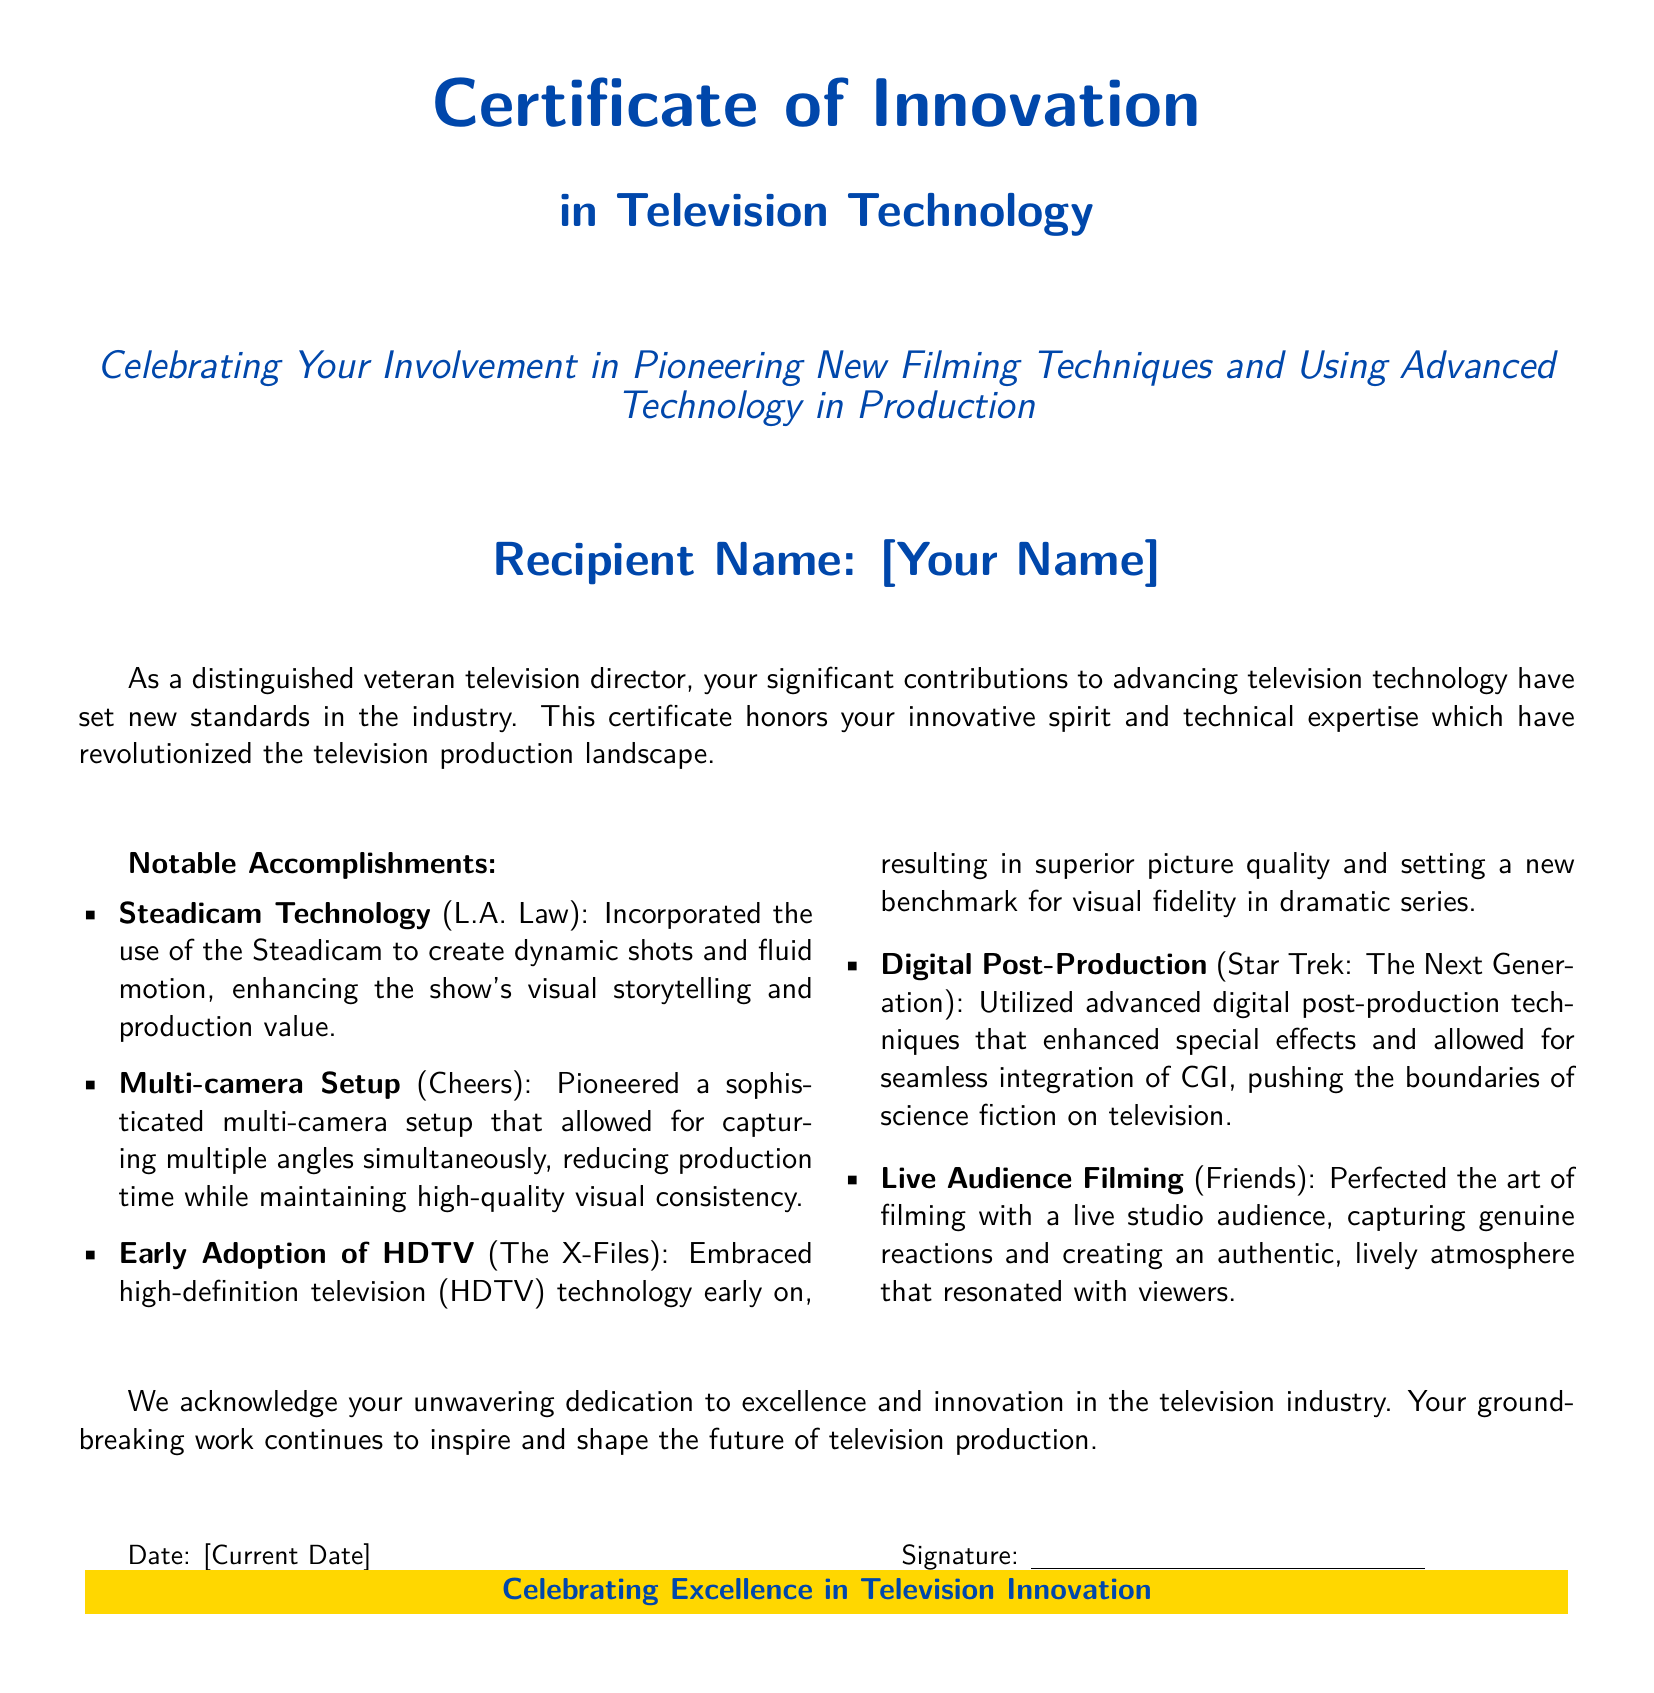What is the title of the certificate? The title is prominently displayed at the top of the document, stating the purpose of the award.
Answer: Certificate of Innovation in Television Technology Who is the recipient of the certificate? The recipient's name is marked in a designated area in the document.
Answer: [Your Name] What is celebrated by this certificate? The document explicitly states what is being recognized and honored.
Answer: Pioneering new filming techniques and using advanced technology in production In which show was Steadicam technology used? The document lists notable accomplishments and mentions specific shows associated with each technique.
Answer: L.A. Law What production technique did the show "Cheers" utilize? The document details specific innovations and the associated shows, highlighting their production techniques.
Answer: Multi-camera Setup What technology did "The X-Files" adopt early on? The document outlines a significant innovation related to visual quality and the specific show that embraced it.
Answer: HDTV Which show perfected filming with a live audience? The document points out notable accomplishments that include the audience engagement strategy.
Answer: Friends What is the date section labeled in the document? The document includes a designated area for the date, indicating when the certificate is issued.
Answer: Date What color is used in the header of the certificate? The document specifies the color theme presented in various sections, especially in headers.
Answer: tvblue 